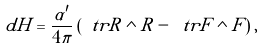Convert formula to latex. <formula><loc_0><loc_0><loc_500><loc_500>d H = \frac { \alpha ^ { \prime } } { 4 \pi } \left ( \ t r R \wedge R - \ t r F \wedge F \right ) ,</formula> 